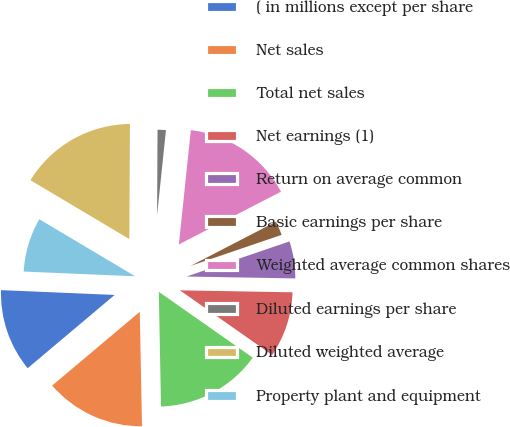Convert chart. <chart><loc_0><loc_0><loc_500><loc_500><pie_chart><fcel>( in millions except per share<fcel>Net sales<fcel>Total net sales<fcel>Net earnings (1)<fcel>Return on average common<fcel>Basic earnings per share<fcel>Weighted average common shares<fcel>Diluted earnings per share<fcel>Diluted weighted average<fcel>Property plant and equipment<nl><fcel>11.81%<fcel>14.17%<fcel>14.96%<fcel>9.45%<fcel>5.51%<fcel>2.36%<fcel>15.75%<fcel>1.57%<fcel>16.54%<fcel>7.87%<nl></chart> 